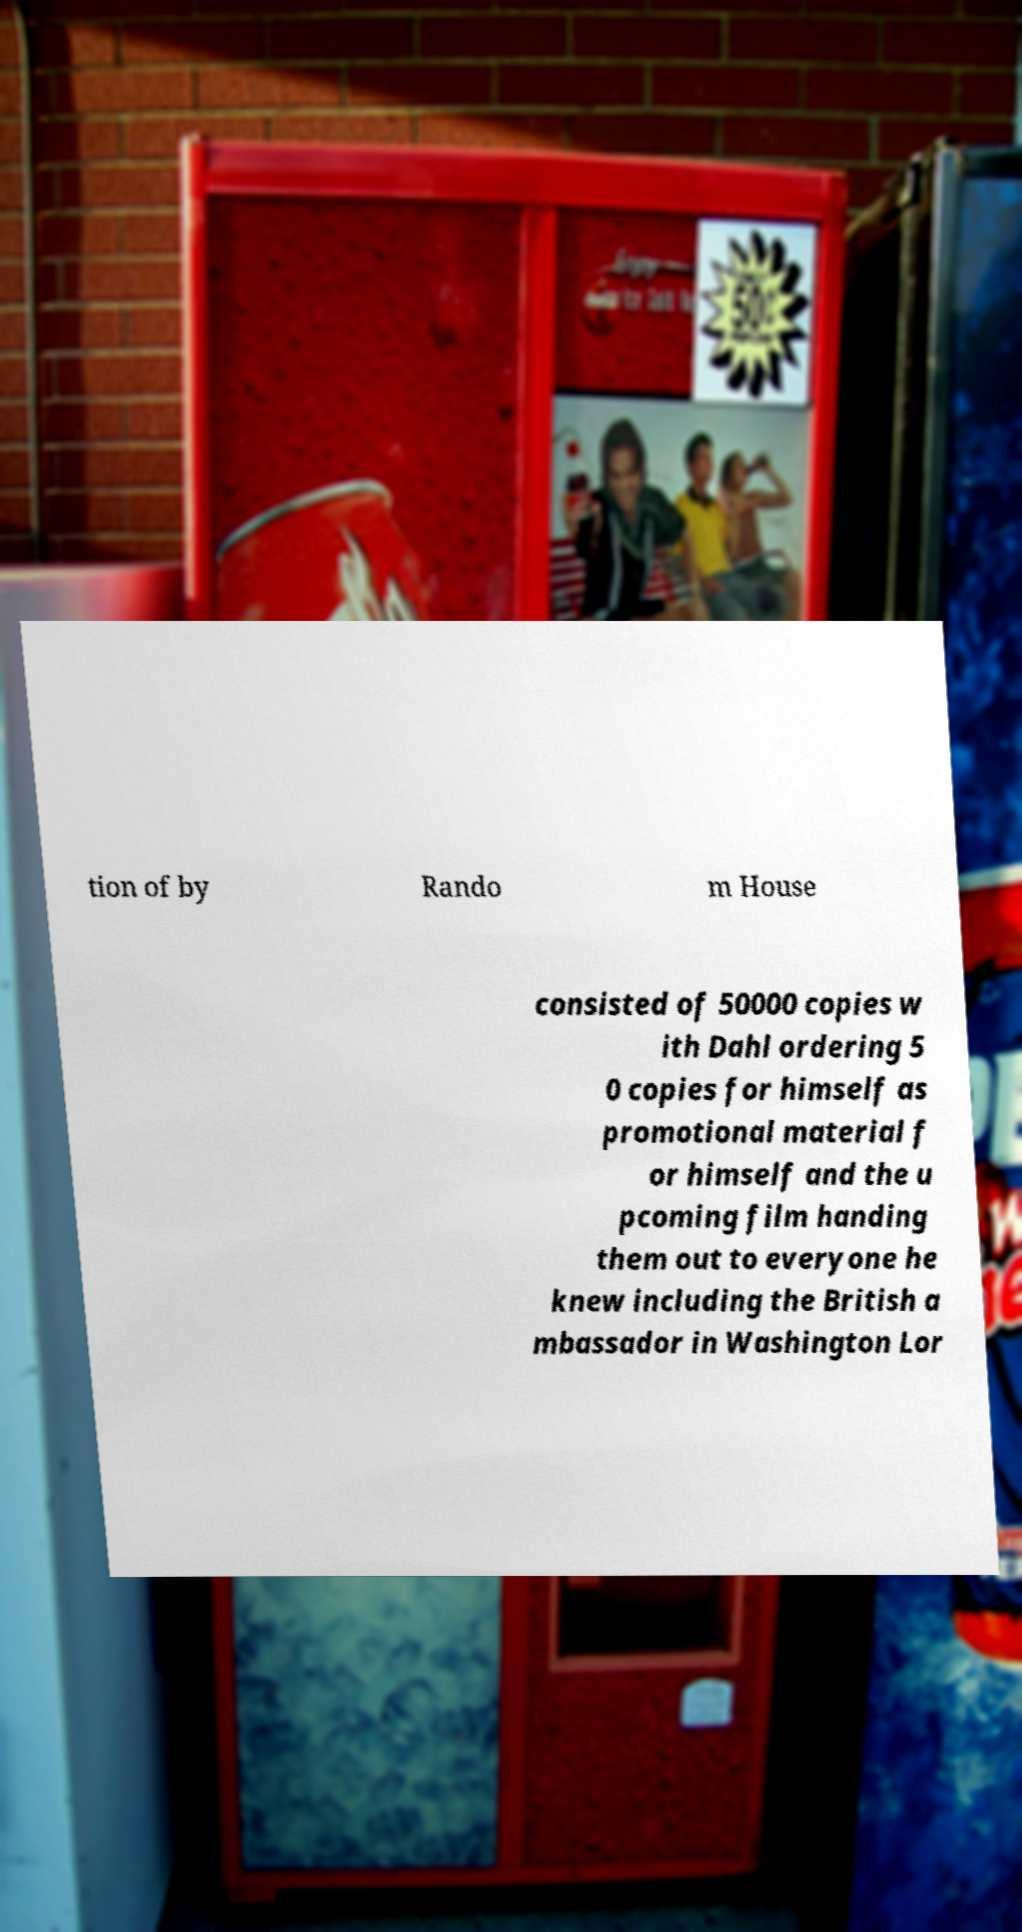Can you read and provide the text displayed in the image?This photo seems to have some interesting text. Can you extract and type it out for me? tion of by Rando m House consisted of 50000 copies w ith Dahl ordering 5 0 copies for himself as promotional material f or himself and the u pcoming film handing them out to everyone he knew including the British a mbassador in Washington Lor 